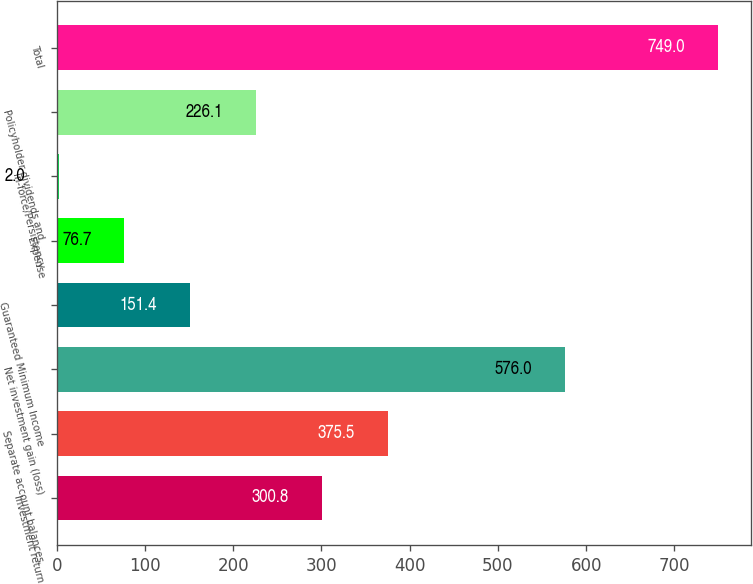<chart> <loc_0><loc_0><loc_500><loc_500><bar_chart><fcel>Investment return<fcel>Separate account balances<fcel>Net investment gain (loss)<fcel>Guaranteed Minimum Income<fcel>Expense<fcel>In-force/Persistency<fcel>Policyholder dividends and<fcel>Total<nl><fcel>300.8<fcel>375.5<fcel>576<fcel>151.4<fcel>76.7<fcel>2<fcel>226.1<fcel>749<nl></chart> 